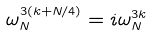<formula> <loc_0><loc_0><loc_500><loc_500>\omega _ { N } ^ { 3 ( k + N / 4 ) } = i \omega _ { N } ^ { 3 k }</formula> 